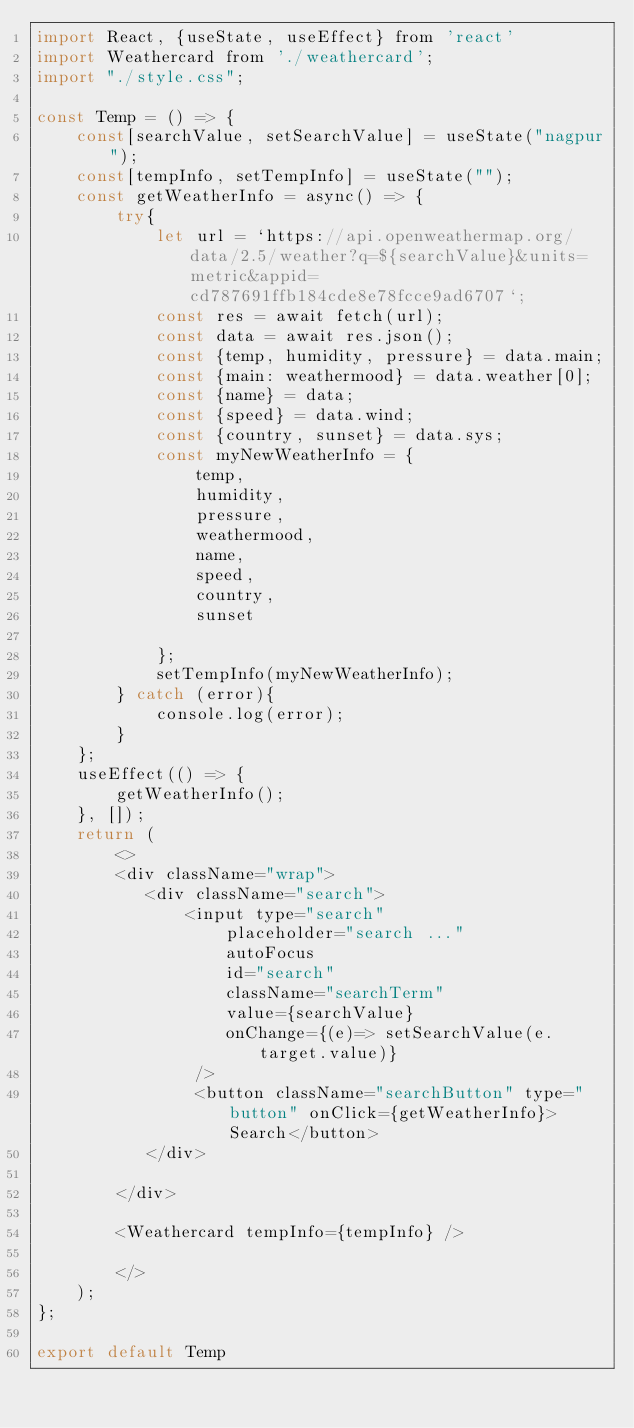<code> <loc_0><loc_0><loc_500><loc_500><_JavaScript_>import React, {useState, useEffect} from 'react'
import Weathercard from './weathercard';
import "./style.css";

const Temp = () => {
    const[searchValue, setSearchValue] = useState("nagpur");
    const[tempInfo, setTempInfo] = useState("");
    const getWeatherInfo = async() => {
        try{
            let url = `https://api.openweathermap.org/data/2.5/weather?q=${searchValue}&units=metric&appid=cd787691ffb184cde8e78fcce9ad6707`;
            const res = await fetch(url);
            const data = await res.json();
            const {temp, humidity, pressure} = data.main;
            const {main: weathermood} = data.weather[0];
            const {name} = data;
            const {speed} = data.wind;
            const {country, sunset} = data.sys;
            const myNewWeatherInfo = {
                temp,
                humidity,
                pressure,
                weathermood,
                name,
                speed,
                country,
                sunset

            };
            setTempInfo(myNewWeatherInfo);
        } catch (error){
            console.log(error);
        }
    };
    useEffect(() => {
        getWeatherInfo();
    }, []);
    return (
        <>
        <div className="wrap">
           <div className="search">
               <input type="search"
                   placeholder="search ..."
                   autoFocus
                   id="search"
                   className="searchTerm"
                   value={searchValue}
                   onChange={(e)=> setSearchValue(e.target.value)}
                />
                <button className="searchButton" type="button" onClick={getWeatherInfo}>Search</button>
           </div>
            
        </div>

        <Weathercard tempInfo={tempInfo} />
        
        </>
    );
};

export default Temp
</code> 